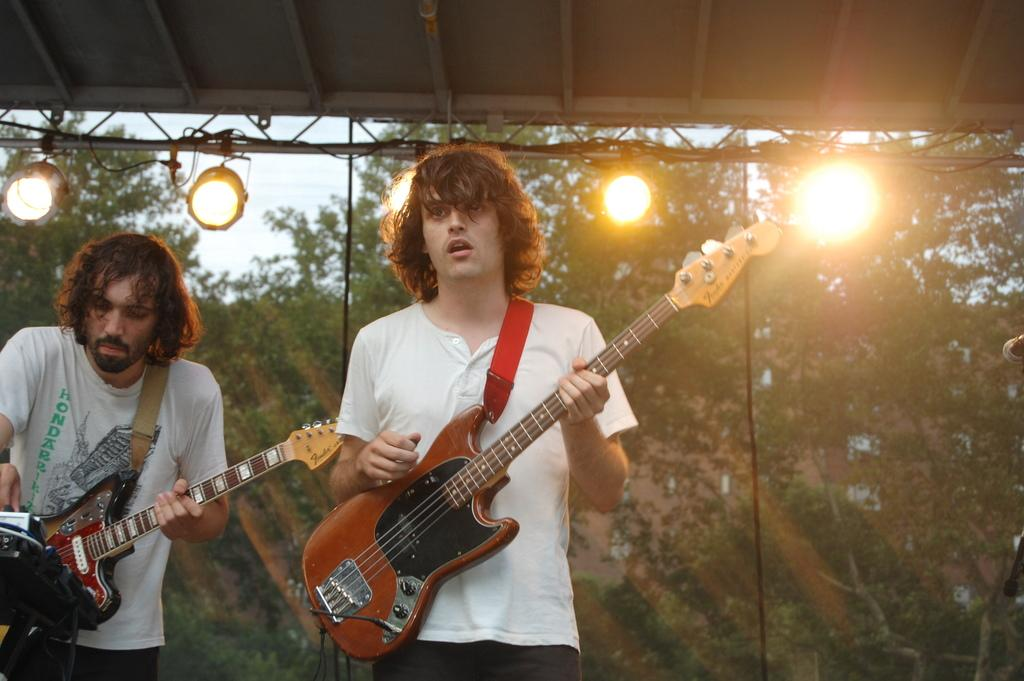How many people are in the image? There are two men in the image. What are the men doing in the image? The men are holding guitars and playing them. What can be seen in the background of the image? There are lights and trees visible in the background. What type of wine is the doctor recommending in the image? There is no doctor or wine present in the image; it features two men playing guitars. 